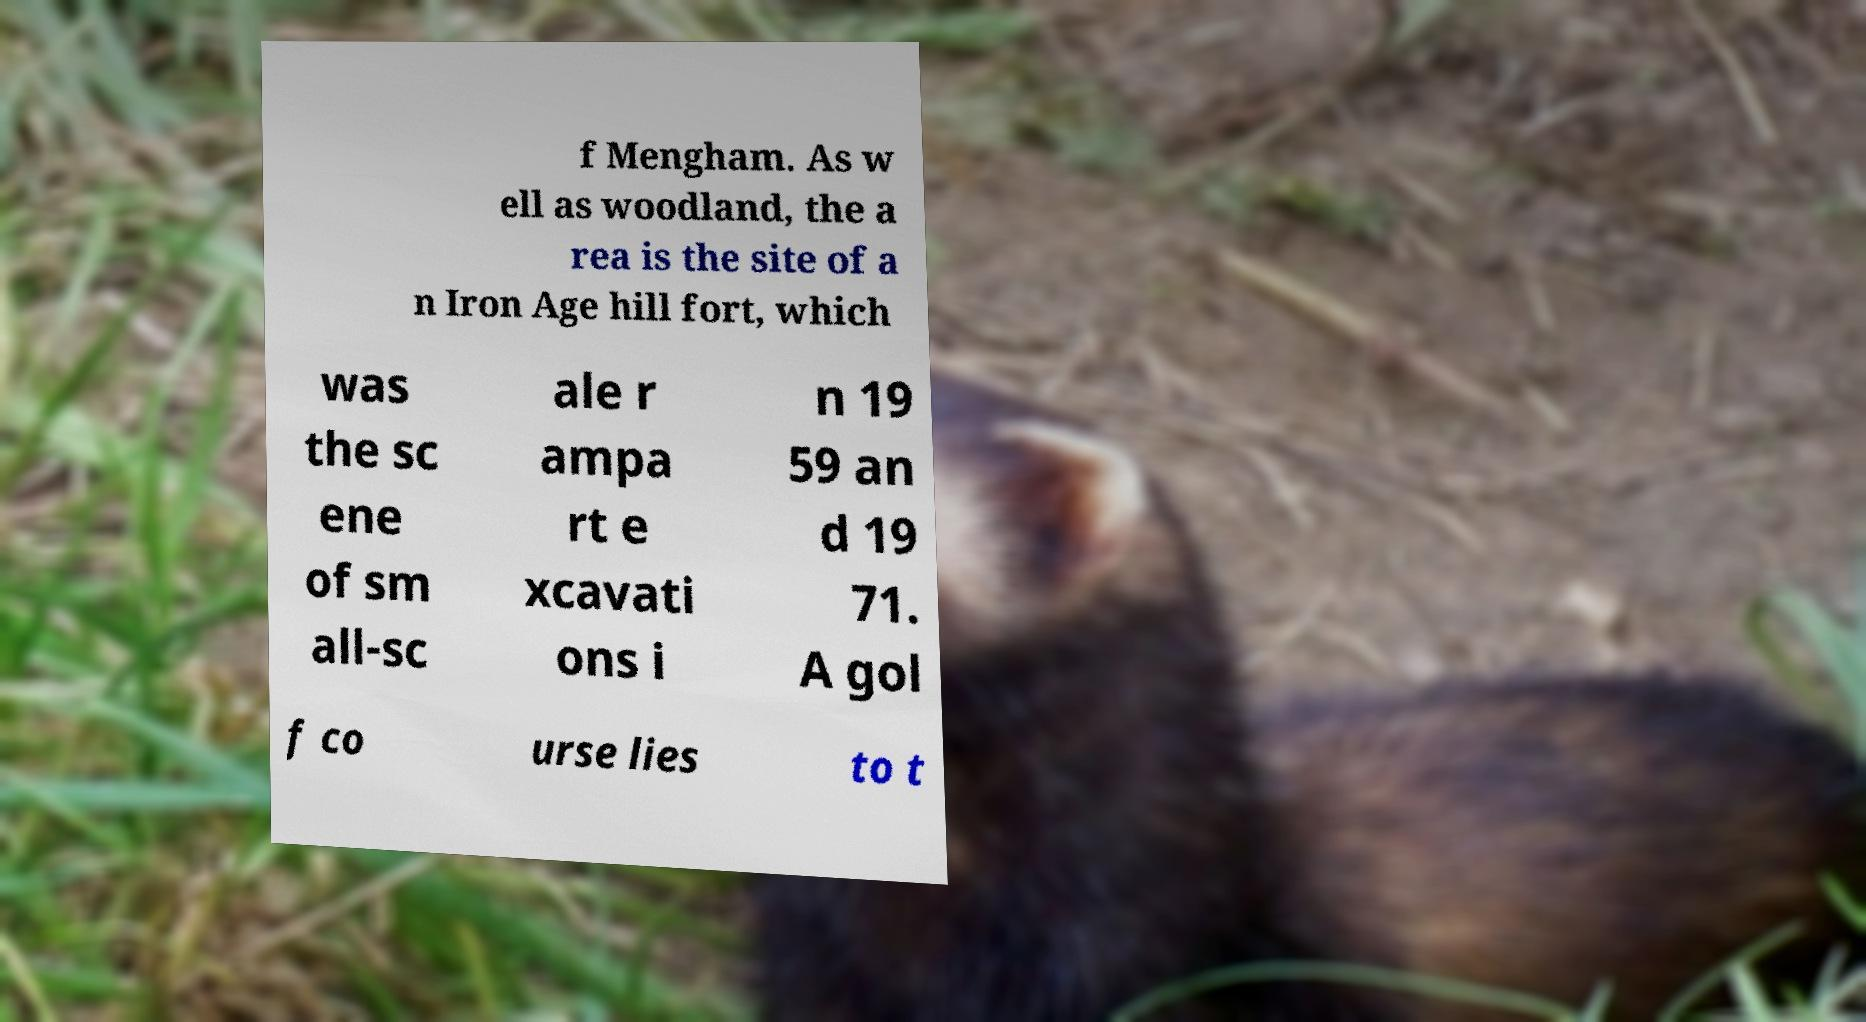What messages or text are displayed in this image? I need them in a readable, typed format. f Mengham. As w ell as woodland, the a rea is the site of a n Iron Age hill fort, which was the sc ene of sm all-sc ale r ampa rt e xcavati ons i n 19 59 an d 19 71. A gol f co urse lies to t 